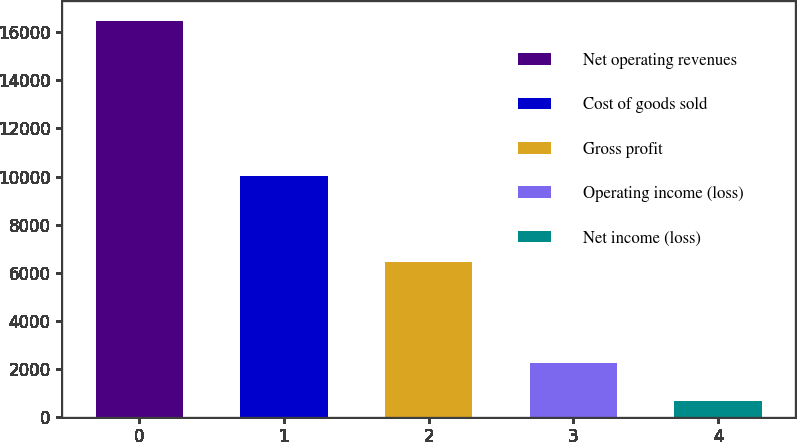Convert chart. <chart><loc_0><loc_0><loc_500><loc_500><bar_chart><fcel>Net operating revenues<fcel>Cost of goods sold<fcel>Gross profit<fcel>Operating income (loss)<fcel>Net income (loss)<nl><fcel>16464<fcel>10028<fcel>6436<fcel>2255.7<fcel>677<nl></chart> 